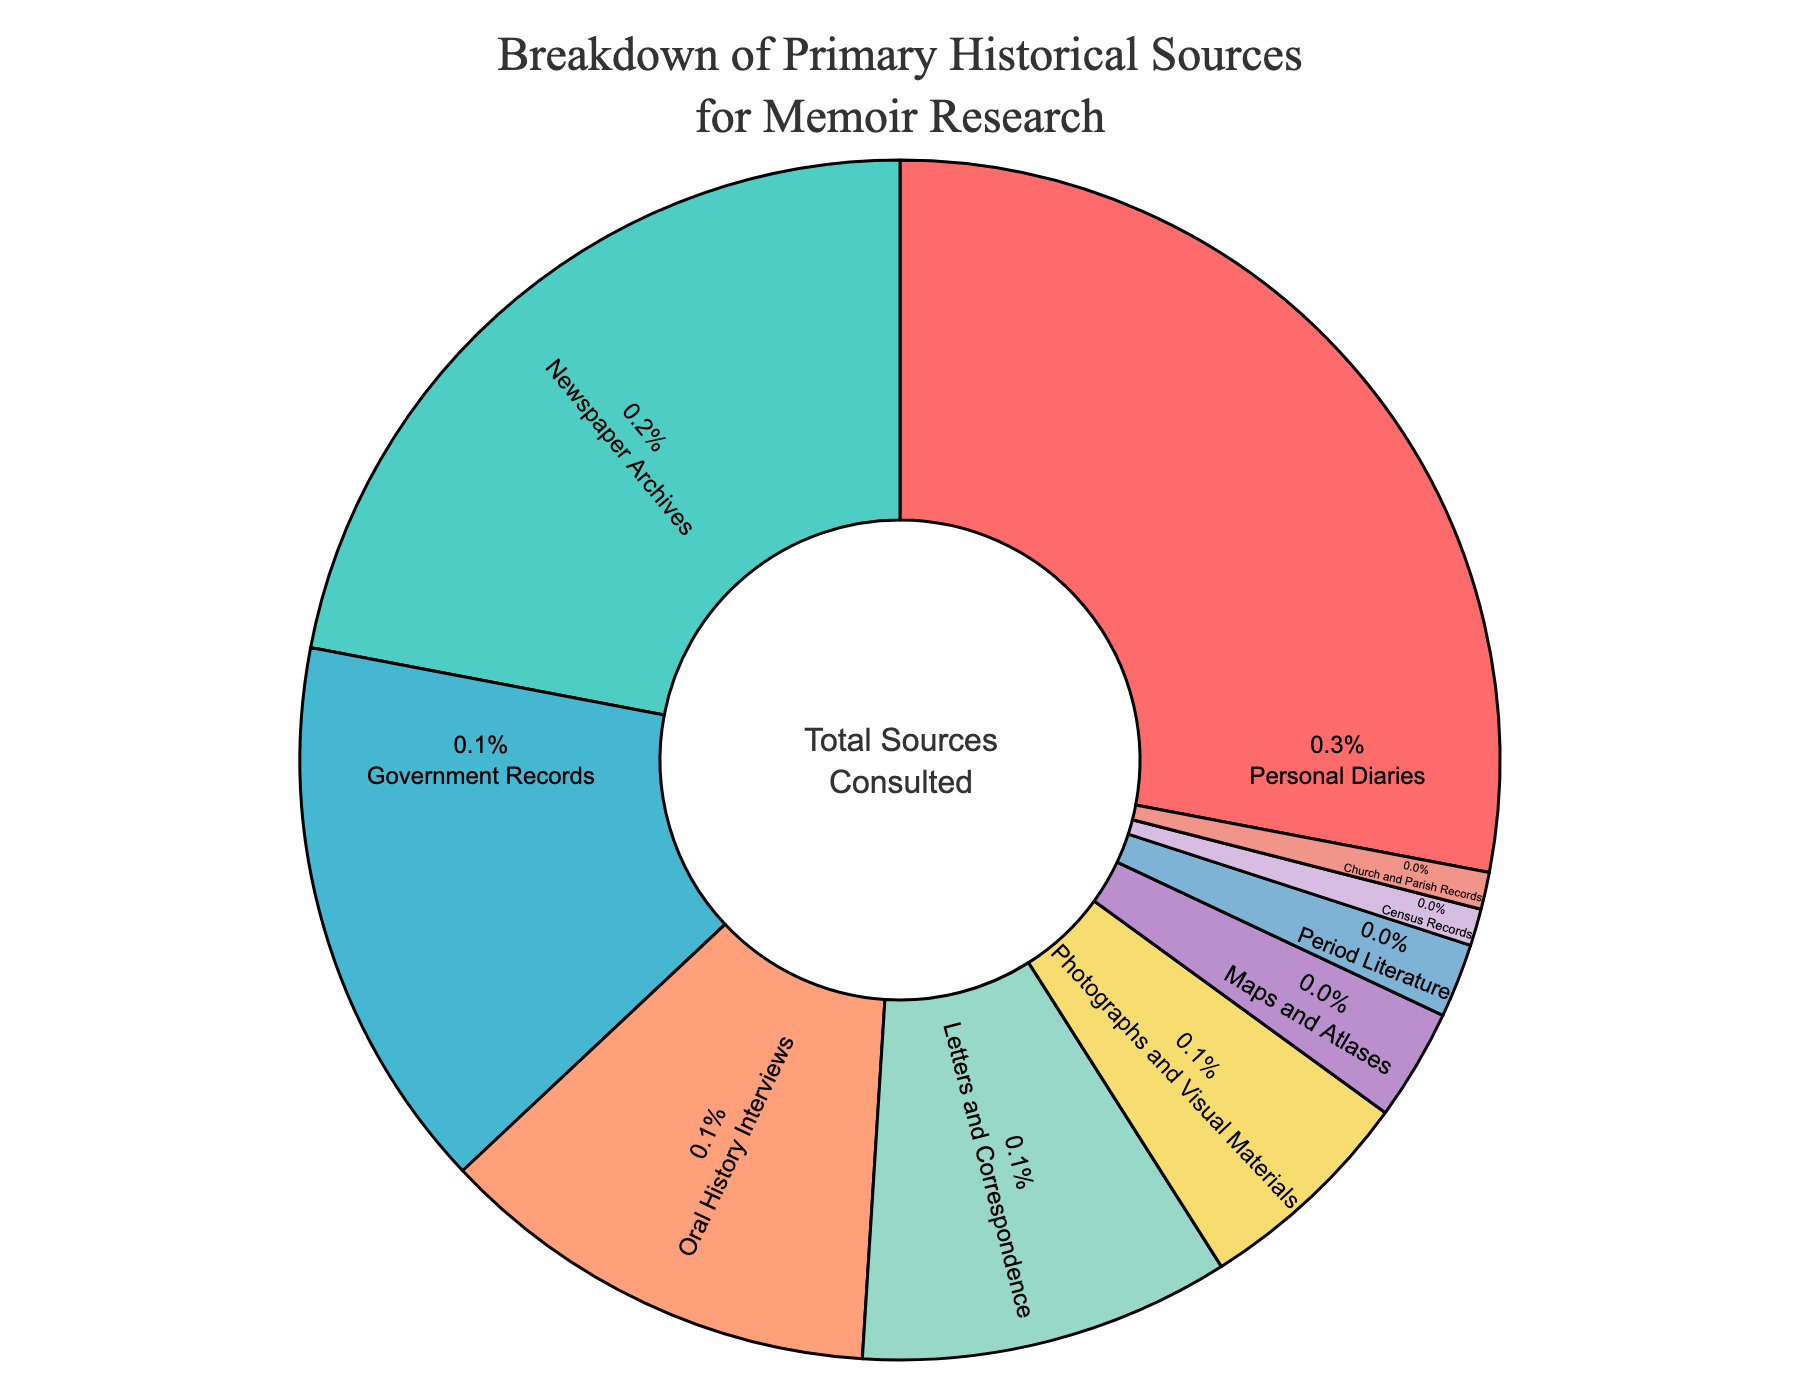What primary historical source type is represented by the largest segment in the pie chart? The largest segment in the pie chart represents the source type with the highest percentage. By observing the chart's segments, the one with the highest percentage is labeled "Personal Diaries".
Answer: Personal Diaries Which two source types have the smallest percentage in the chart? To find the two source types with the smallest percentages, look for the segments with the lowest values. According to the chart, which segments are barely visible and labeled as "Census Records" and "Church and Parish Records," each with a very small percentage.
Answer: Census Records and Church and Parish Records What is the combined percentage of "Newspaper Archives" and "Government Records"? Add the percentages of "Newspaper Archives" (22%) and "Government Records" (15%). Therefore, 22% + 15% = 37%.
Answer: 37% How much greater is the percentage of "Personal Diaries" compared to "Letters and Correspondence"? Subtract the percentage of "Letters and Correspondence" (10%) from "Personal Diaries" (28%). So, 28% - 10% = 18%.
Answer: 18% Which source type has a larger percentage: "Photographs and Visual Materials" or "Oral History Interviews"? Compare the percentage values for "Photographs and Visual Materials" (6%) and "Oral History Interviews" (12%). "Oral History Interviews" has a larger percentage than "Photographs and Visual Materials".
Answer: Oral History Interviews What percentage of the sources fall under "Maps and Atlases" and "Period Literature" combined? Add the percentages of "Maps and Atlases" (3%) and "Period Literature" (2%). Therefore, 3% + 2% = 5%.
Answer: 5% Which color corresponds to the "Newspaper Archives" segment in the pie chart? Identify the segment corresponding to "Newspaper Archives" and note its color. The "Newspaper Archives" segment is marked in a distinct color, which should be identifiable on the chart.
Answer: A specific greenish-blue Estimate how much larger the "Personal Diaries" segment is visually compared to the "Oral History Interviews" segment. Visually estimate based on the size difference between the "Personal Diaries" segment (28%) and the "Oral History Interviews" segment (12%). The "Personal Diaries" segment appears approximately more than twice as large as the "Oral History Interviews" segment.
Answer: More than twice as large 